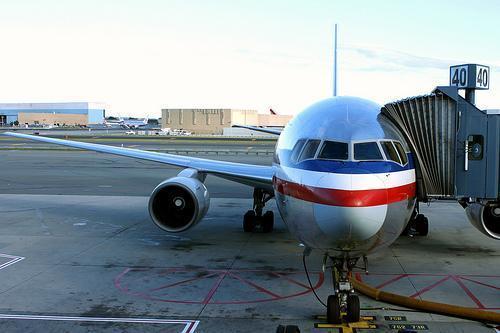How many wings of a plane visible?
Give a very brief answer. 1. How many planes are prominently visible in the picture?
Give a very brief answer. 1. 